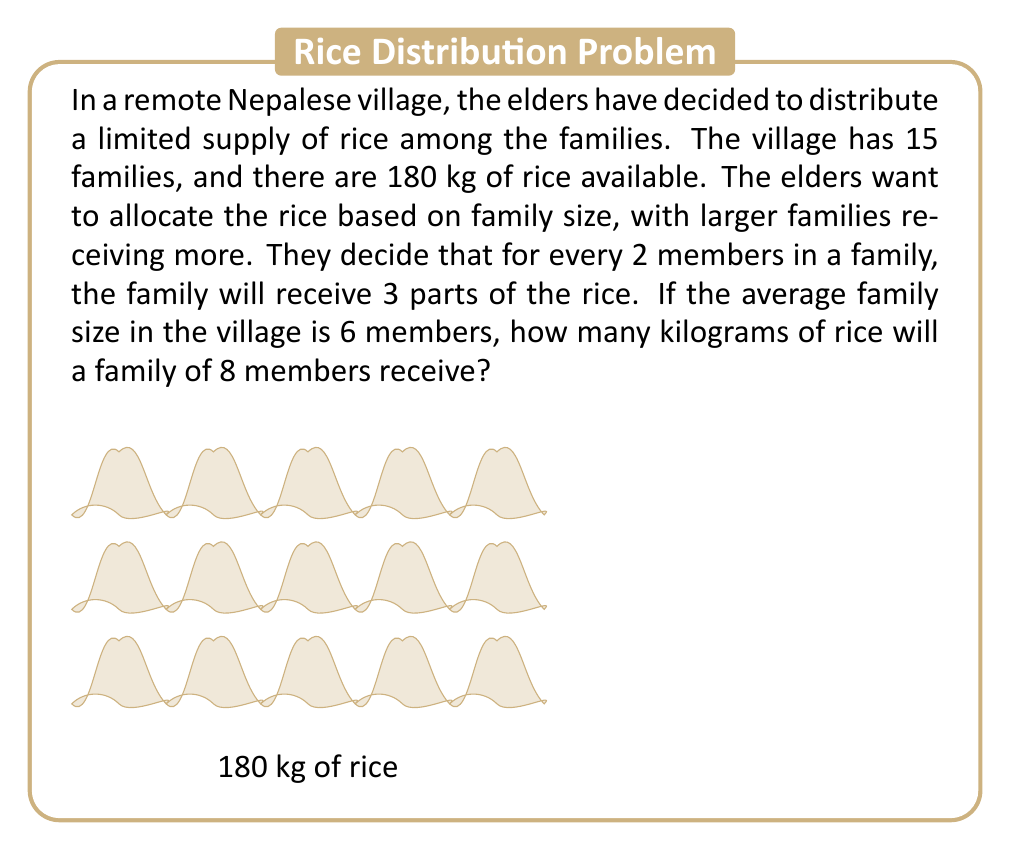Could you help me with this problem? Let's solve this problem step by step:

1) First, we need to calculate the total number of parts for all families:
   - Average family size = 6 members
   - Number of families = 15
   - Parts per family = $\frac{6}{2} \times 3 = 9$ parts
   - Total parts = $15 \times 9 = 135$ parts

2) Now we can calculate how much rice each part represents:
   $\frac{\text{Total rice}}{\text{Total parts}} = \frac{180 \text{ kg}}{135} = \frac{4}{3} \text{ kg per part}$

3) For a family of 8 members:
   - Number of parts = $\frac{8}{2} \times 3 = 12$ parts

4) Amount of rice for this family:
   $12 \text{ parts} \times \frac{4}{3} \text{ kg/part} = 16 \text{ kg}$

Therefore, a family of 8 members will receive 16 kg of rice.
Answer: 16 kg 